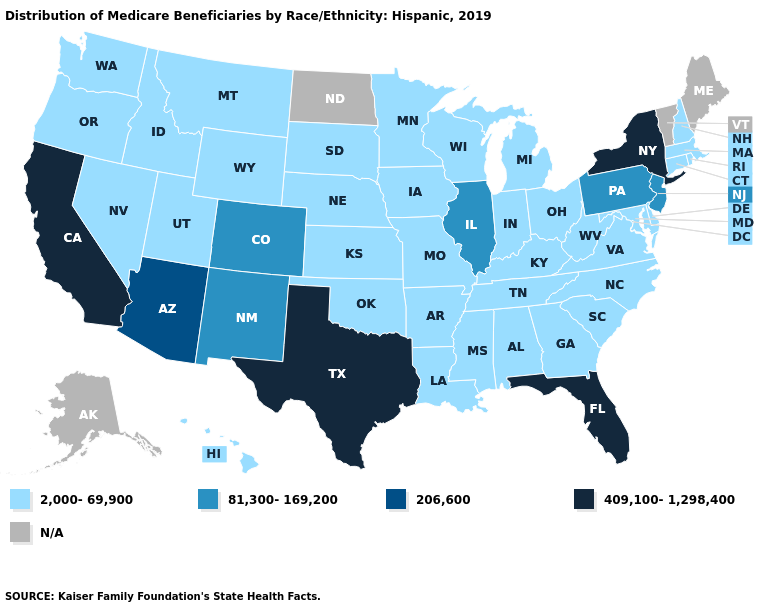Which states have the lowest value in the USA?
Be succinct. Alabama, Arkansas, Connecticut, Delaware, Georgia, Hawaii, Idaho, Indiana, Iowa, Kansas, Kentucky, Louisiana, Maryland, Massachusetts, Michigan, Minnesota, Mississippi, Missouri, Montana, Nebraska, Nevada, New Hampshire, North Carolina, Ohio, Oklahoma, Oregon, Rhode Island, South Carolina, South Dakota, Tennessee, Utah, Virginia, Washington, West Virginia, Wisconsin, Wyoming. What is the value of Virginia?
Quick response, please. 2,000-69,900. Which states have the lowest value in the USA?
Short answer required. Alabama, Arkansas, Connecticut, Delaware, Georgia, Hawaii, Idaho, Indiana, Iowa, Kansas, Kentucky, Louisiana, Maryland, Massachusetts, Michigan, Minnesota, Mississippi, Missouri, Montana, Nebraska, Nevada, New Hampshire, North Carolina, Ohio, Oklahoma, Oregon, Rhode Island, South Carolina, South Dakota, Tennessee, Utah, Virginia, Washington, West Virginia, Wisconsin, Wyoming. Name the states that have a value in the range 206,600?
Be succinct. Arizona. What is the value of New York?
Concise answer only. 409,100-1,298,400. Does Maryland have the lowest value in the USA?
Keep it brief. Yes. Name the states that have a value in the range 2,000-69,900?
Be succinct. Alabama, Arkansas, Connecticut, Delaware, Georgia, Hawaii, Idaho, Indiana, Iowa, Kansas, Kentucky, Louisiana, Maryland, Massachusetts, Michigan, Minnesota, Mississippi, Missouri, Montana, Nebraska, Nevada, New Hampshire, North Carolina, Ohio, Oklahoma, Oregon, Rhode Island, South Carolina, South Dakota, Tennessee, Utah, Virginia, Washington, West Virginia, Wisconsin, Wyoming. Which states have the lowest value in the USA?
Be succinct. Alabama, Arkansas, Connecticut, Delaware, Georgia, Hawaii, Idaho, Indiana, Iowa, Kansas, Kentucky, Louisiana, Maryland, Massachusetts, Michigan, Minnesota, Mississippi, Missouri, Montana, Nebraska, Nevada, New Hampshire, North Carolina, Ohio, Oklahoma, Oregon, Rhode Island, South Carolina, South Dakota, Tennessee, Utah, Virginia, Washington, West Virginia, Wisconsin, Wyoming. How many symbols are there in the legend?
Concise answer only. 5. Name the states that have a value in the range 409,100-1,298,400?
Be succinct. California, Florida, New York, Texas. Name the states that have a value in the range N/A?
Concise answer only. Alaska, Maine, North Dakota, Vermont. Name the states that have a value in the range 409,100-1,298,400?
Short answer required. California, Florida, New York, Texas. Is the legend a continuous bar?
Give a very brief answer. No. Name the states that have a value in the range N/A?
Concise answer only. Alaska, Maine, North Dakota, Vermont. 